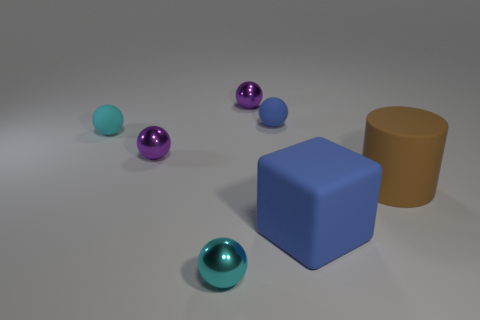Describe the size relationships among the objects. In this image, we observe a variety of sizes. The large blue cube and the brown cylinder appear to be the largest objects. The rubber spheres come in different sizes, with the blue one being noticeably the smallest. The other spheres seem to be of a similar size but smaller than the large blue cube and brown cylinder. 